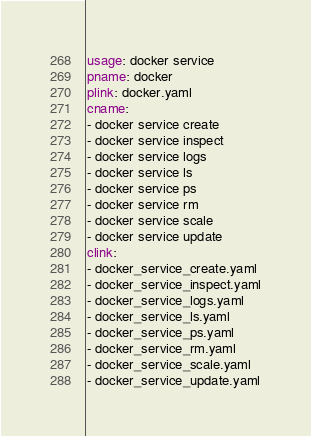Convert code to text. <code><loc_0><loc_0><loc_500><loc_500><_YAML_>usage: docker service
pname: docker
plink: docker.yaml
cname:
- docker service create
- docker service inspect
- docker service logs
- docker service ls
- docker service ps
- docker service rm
- docker service scale
- docker service update
clink:
- docker_service_create.yaml
- docker_service_inspect.yaml
- docker_service_logs.yaml
- docker_service_ls.yaml
- docker_service_ps.yaml
- docker_service_rm.yaml
- docker_service_scale.yaml
- docker_service_update.yaml

</code> 